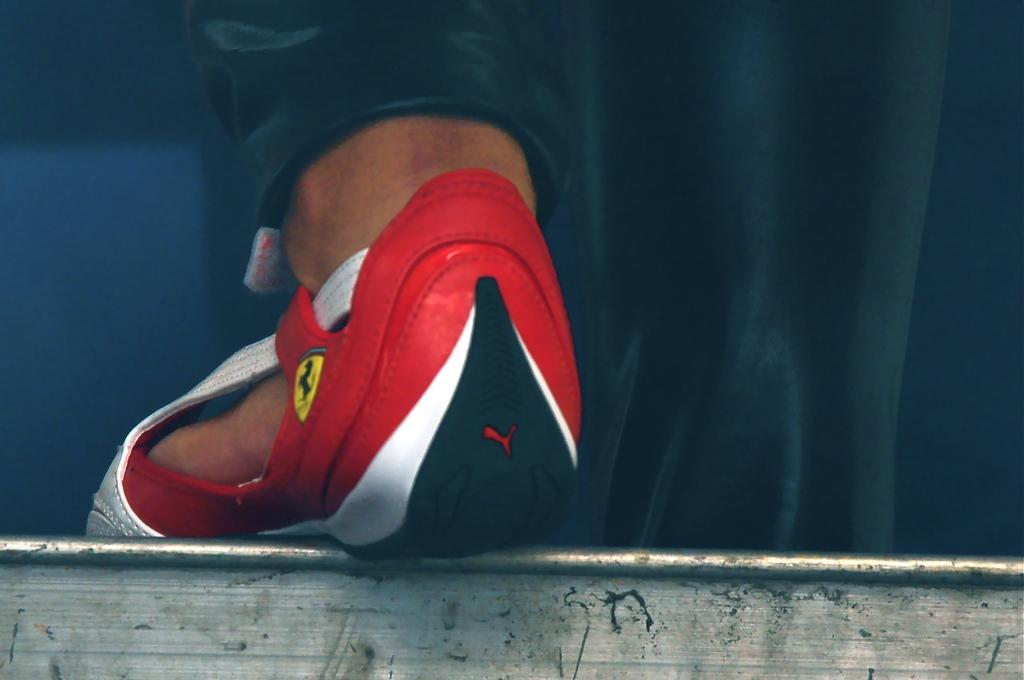What part of a person can be seen in the image? There is a leg of a person in the image. What type of footwear is the person wearing? The person is wearing a red shoe. Can you describe any other visual elements in the image? There is a yellow color logo in the image. What type of pickle is being used as an ornament on the person's leg in the image? There is no pickle or ornament present on the person's leg in the image. 